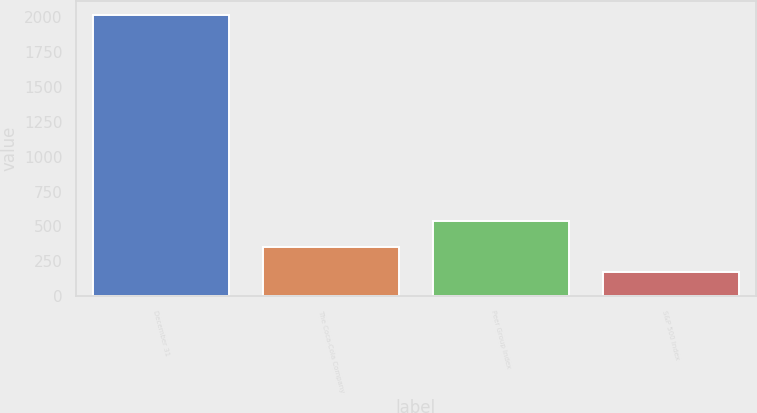Convert chart. <chart><loc_0><loc_0><loc_500><loc_500><bar_chart><fcel>December 31<fcel>The Coca-Cola Company<fcel>Peer Group Index<fcel>S&P 500 Index<nl><fcel>2012<fcel>356<fcel>540<fcel>172<nl></chart> 